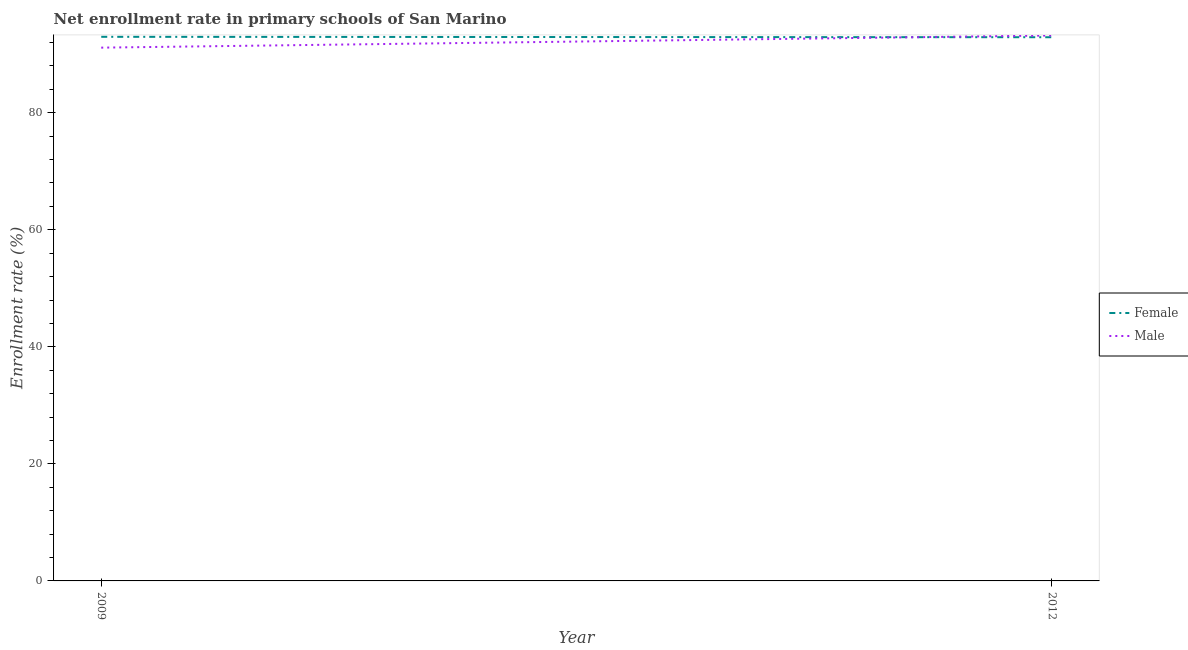How many different coloured lines are there?
Provide a succinct answer. 2. Is the number of lines equal to the number of legend labels?
Your response must be concise. Yes. What is the enrollment rate of male students in 2012?
Make the answer very short. 93.2. Across all years, what is the maximum enrollment rate of male students?
Offer a terse response. 93.2. Across all years, what is the minimum enrollment rate of male students?
Keep it short and to the point. 91.12. What is the total enrollment rate of male students in the graph?
Offer a very short reply. 184.33. What is the difference between the enrollment rate of female students in 2009 and that in 2012?
Offer a terse response. 0.07. What is the difference between the enrollment rate of male students in 2009 and the enrollment rate of female students in 2012?
Offer a terse response. -1.78. What is the average enrollment rate of male students per year?
Your answer should be very brief. 92.16. In the year 2009, what is the difference between the enrollment rate of female students and enrollment rate of male students?
Your answer should be very brief. 1.85. What is the ratio of the enrollment rate of male students in 2009 to that in 2012?
Your answer should be compact. 0.98. Does the enrollment rate of female students monotonically increase over the years?
Keep it short and to the point. No. Is the enrollment rate of male students strictly greater than the enrollment rate of female students over the years?
Your response must be concise. No. Is the enrollment rate of female students strictly less than the enrollment rate of male students over the years?
Ensure brevity in your answer.  No. Are the values on the major ticks of Y-axis written in scientific E-notation?
Your answer should be very brief. No. Where does the legend appear in the graph?
Provide a succinct answer. Center right. What is the title of the graph?
Make the answer very short. Net enrollment rate in primary schools of San Marino. Does "Money lenders" appear as one of the legend labels in the graph?
Provide a short and direct response. No. What is the label or title of the X-axis?
Make the answer very short. Year. What is the label or title of the Y-axis?
Your answer should be compact. Enrollment rate (%). What is the Enrollment rate (%) in Female in 2009?
Your answer should be very brief. 92.97. What is the Enrollment rate (%) in Male in 2009?
Make the answer very short. 91.12. What is the Enrollment rate (%) in Female in 2012?
Offer a very short reply. 92.9. What is the Enrollment rate (%) in Male in 2012?
Offer a very short reply. 93.2. Across all years, what is the maximum Enrollment rate (%) in Female?
Your response must be concise. 92.97. Across all years, what is the maximum Enrollment rate (%) in Male?
Provide a succinct answer. 93.2. Across all years, what is the minimum Enrollment rate (%) in Female?
Your answer should be compact. 92.9. Across all years, what is the minimum Enrollment rate (%) of Male?
Offer a very short reply. 91.12. What is the total Enrollment rate (%) of Female in the graph?
Keep it short and to the point. 185.88. What is the total Enrollment rate (%) in Male in the graph?
Provide a succinct answer. 184.33. What is the difference between the Enrollment rate (%) in Female in 2009 and that in 2012?
Offer a terse response. 0.07. What is the difference between the Enrollment rate (%) in Male in 2009 and that in 2012?
Offer a very short reply. -2.08. What is the difference between the Enrollment rate (%) of Female in 2009 and the Enrollment rate (%) of Male in 2012?
Keep it short and to the point. -0.23. What is the average Enrollment rate (%) in Female per year?
Your answer should be compact. 92.94. What is the average Enrollment rate (%) of Male per year?
Your response must be concise. 92.16. In the year 2009, what is the difference between the Enrollment rate (%) of Female and Enrollment rate (%) of Male?
Your response must be concise. 1.85. In the year 2012, what is the difference between the Enrollment rate (%) in Female and Enrollment rate (%) in Male?
Your answer should be compact. -0.3. What is the ratio of the Enrollment rate (%) in Female in 2009 to that in 2012?
Your response must be concise. 1. What is the ratio of the Enrollment rate (%) of Male in 2009 to that in 2012?
Offer a terse response. 0.98. What is the difference between the highest and the second highest Enrollment rate (%) of Female?
Keep it short and to the point. 0.07. What is the difference between the highest and the second highest Enrollment rate (%) in Male?
Provide a succinct answer. 2.08. What is the difference between the highest and the lowest Enrollment rate (%) of Female?
Offer a very short reply. 0.07. What is the difference between the highest and the lowest Enrollment rate (%) of Male?
Offer a very short reply. 2.08. 